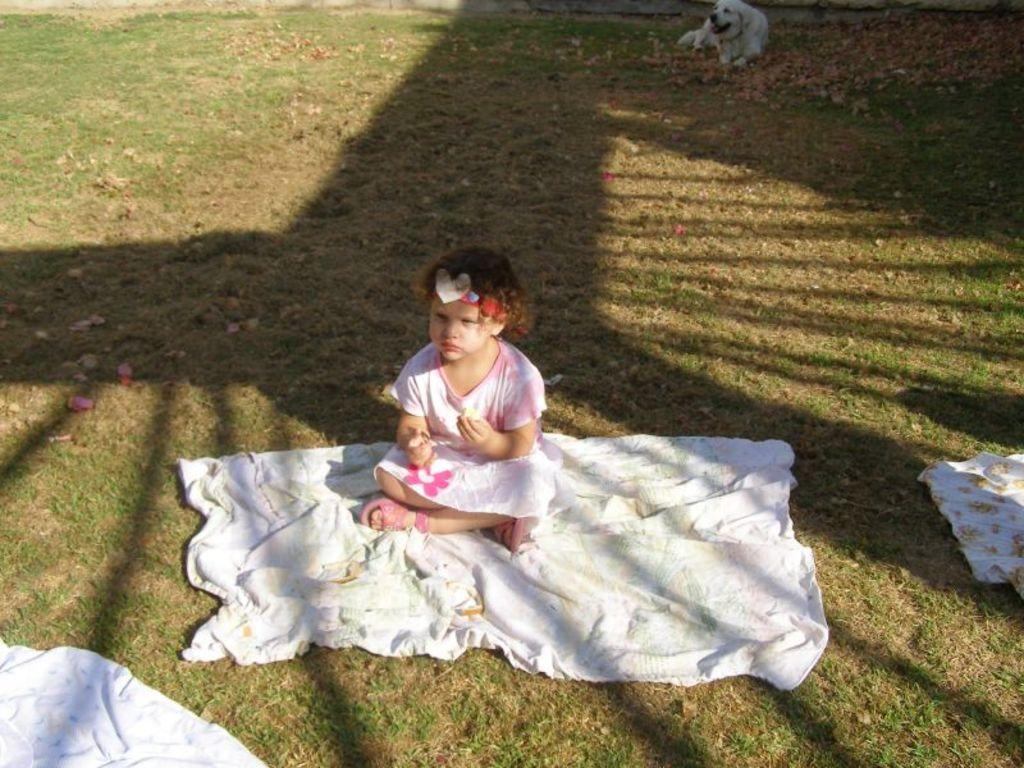What is the child sitting on in the image? The child is sitting on a cloth in the image. Where is the cloth located? The cloth is on the surface of the grass. Are there any other clothes visible in the image? Yes, there are other clothes nearby. What can be seen in the background of the image? There is a dog in the background of the image. What is the price of the vessel in the image? There is no vessel present in the image, so it is not possible to determine its price. 